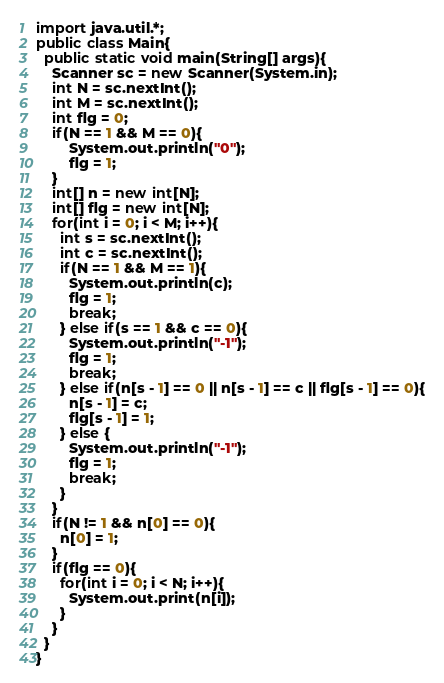Convert code to text. <code><loc_0><loc_0><loc_500><loc_500><_Java_>import java.util.*;
public class Main{
  public static void main(String[] args){
    Scanner sc = new Scanner(System.in);
    int N = sc.nextInt();
    int M = sc.nextInt();
    int flg = 0;
    if(N == 1 && M == 0){
        System.out.println("0");
        flg = 1;
    }
    int[] n = new int[N];
    int[] flg = new int[N];
    for(int i = 0; i < M; i++){
      int s = sc.nextInt();
      int c = sc.nextInt();
      if(N == 1 && M == 1){
        System.out.println(c);
        flg = 1;
        break;
      } else if(s == 1 && c == 0){
        System.out.println("-1");
        flg = 1;
        break;
      } else if(n[s - 1] == 0 || n[s - 1] == c || flg[s - 1] == 0){
        n[s - 1] = c;
        flg[s - 1] = 1;
      } else {
        System.out.println("-1");
        flg = 1;
        break;
      }
    }
    if(N != 1 && n[0] == 0){
      n[0] = 1;
    }
    if(flg == 0){
      for(int i = 0; i < N; i++){
        System.out.print(n[i]);
      }
    }
  }
}
</code> 